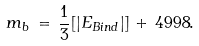<formula> <loc_0><loc_0><loc_500><loc_500>m _ { b } \, = \, \frac { 1 } { 3 } [ | E _ { B i n d } | ] \, + \, 4 9 9 8 .</formula> 